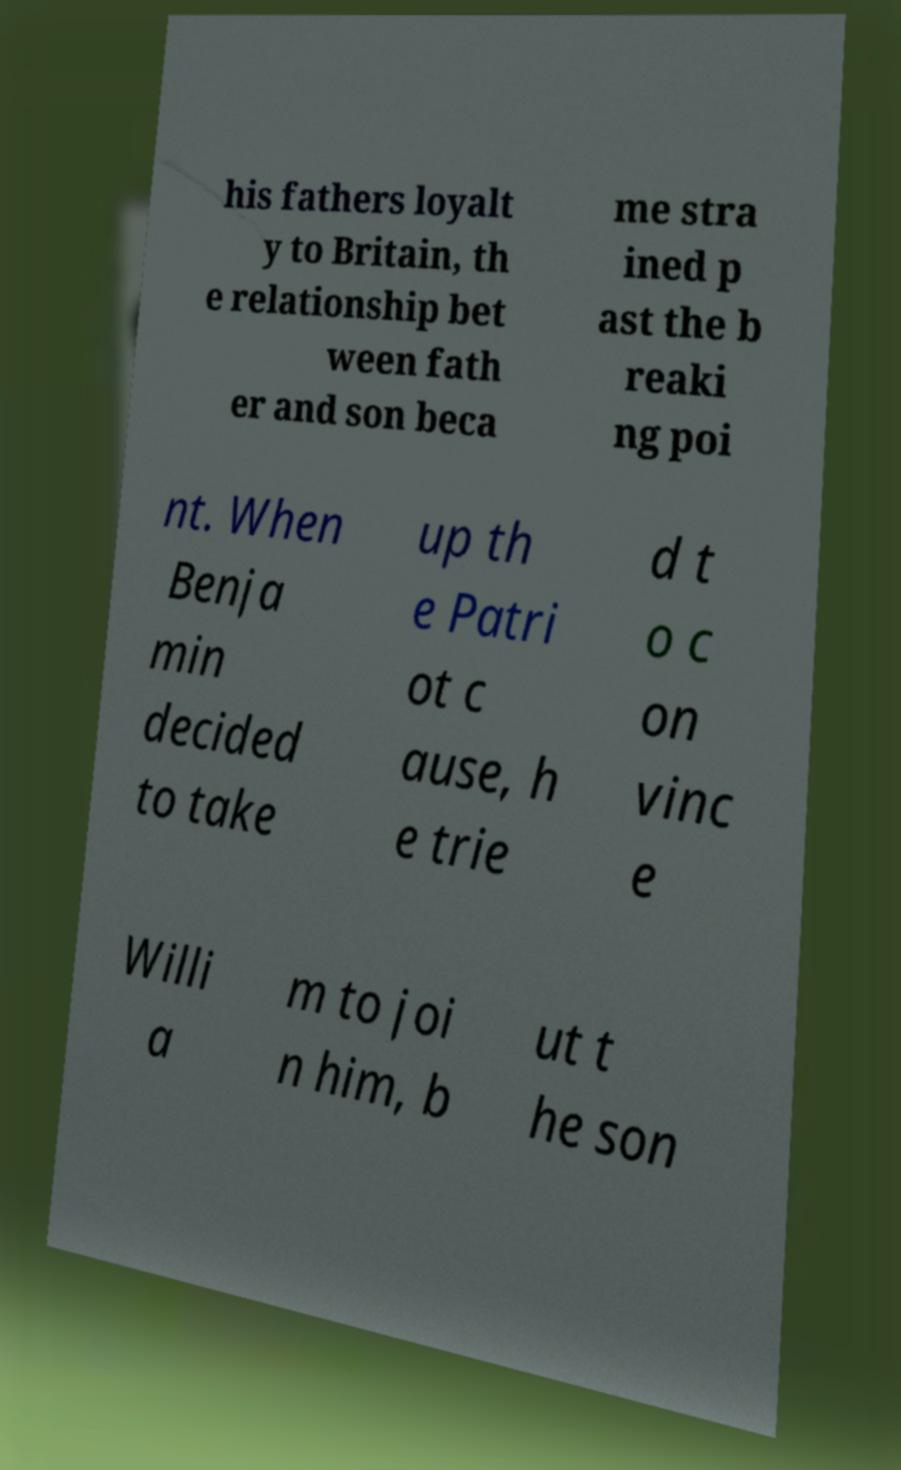Please read and relay the text visible in this image. What does it say? his fathers loyalt y to Britain, th e relationship bet ween fath er and son beca me stra ined p ast the b reaki ng poi nt. When Benja min decided to take up th e Patri ot c ause, h e trie d t o c on vinc e Willi a m to joi n him, b ut t he son 